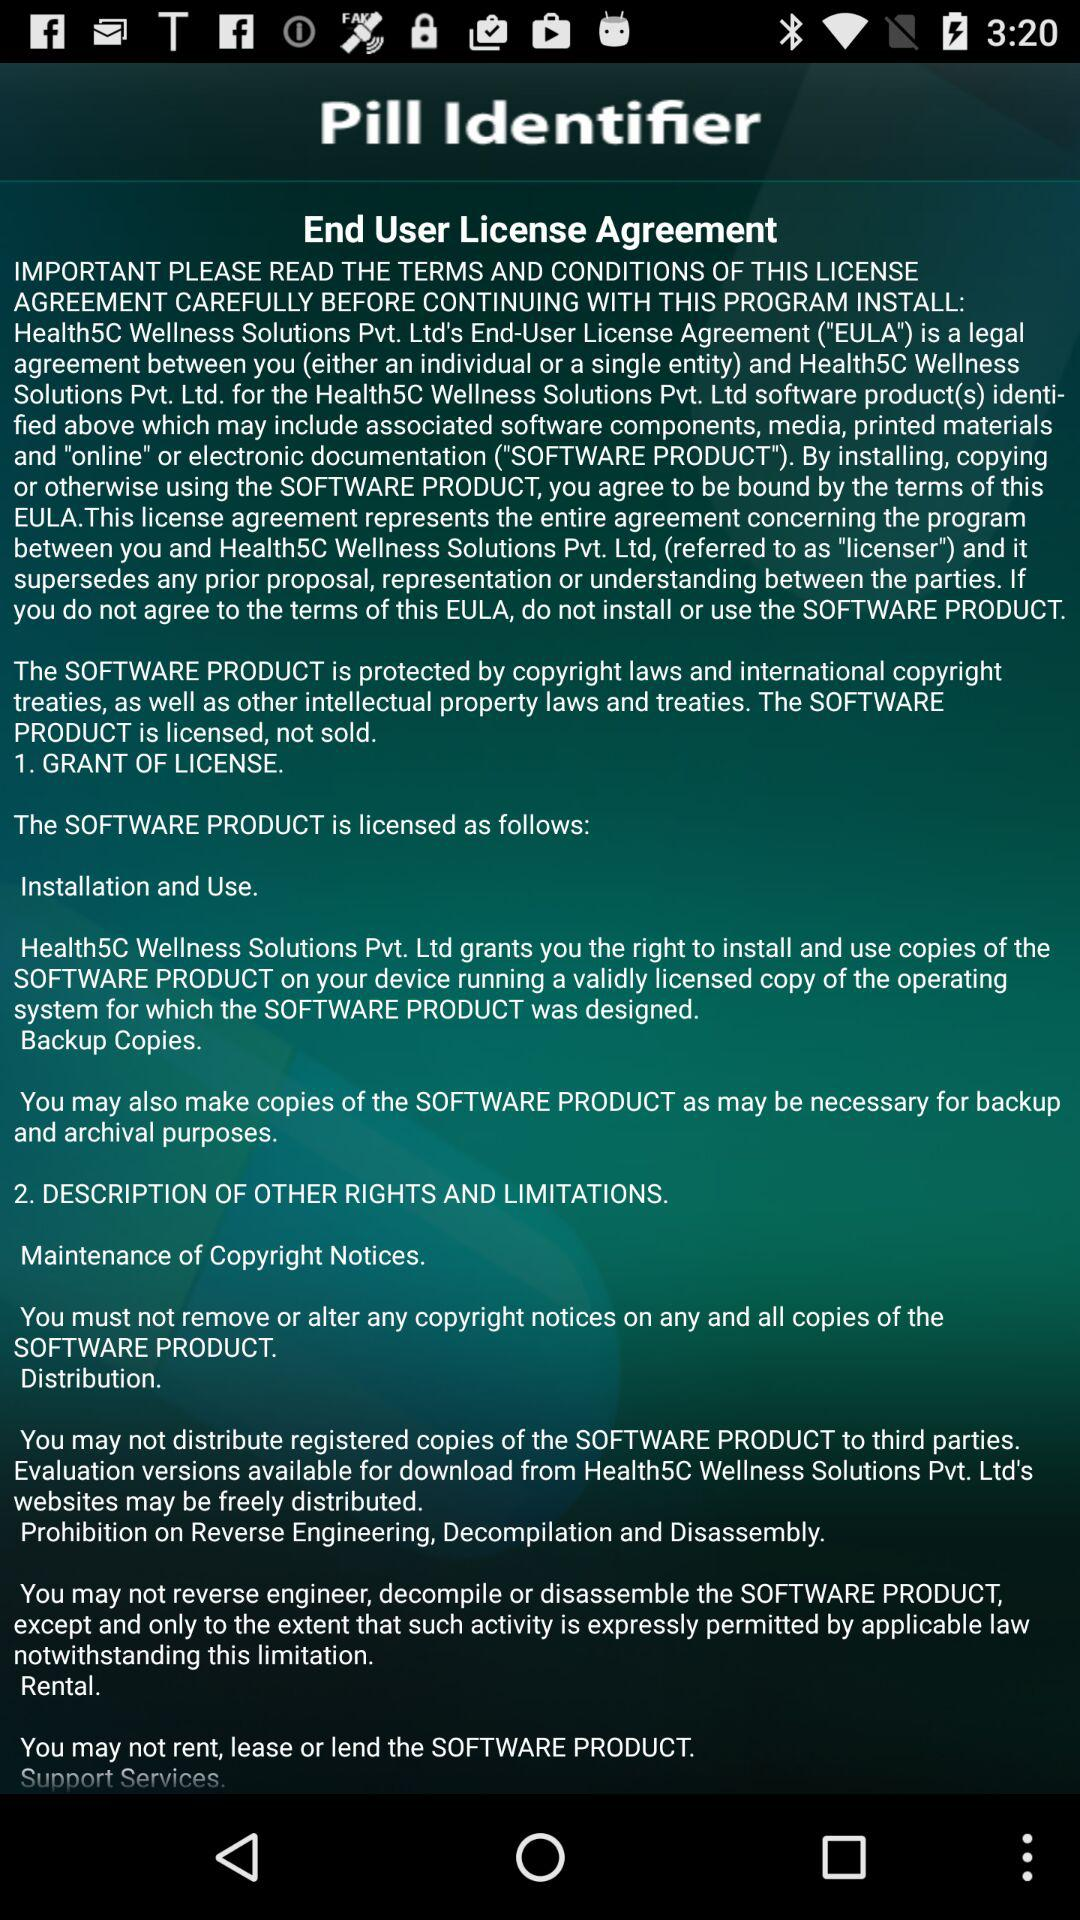What is the End-User License Agreement? The End-User License Agreement is "a legal agreement between you (either an individual or a single entity) and Health5C Wellness Solutions Pvt. Ltd. for the Health5C Wellness Solutions Pvt. Ltd software product(s) identi- fied above which may include associated software components, media, printed materials and "online" or electronic documentation ("SOFTWARE PRODUCT")". 